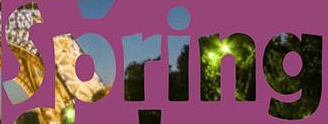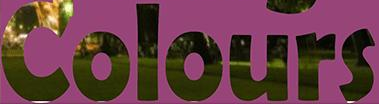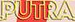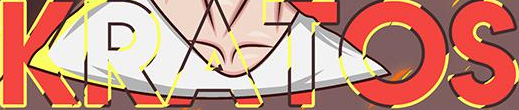Read the text content from these images in order, separated by a semicolon. Spring; Colours; PUTRA; KRATOS 